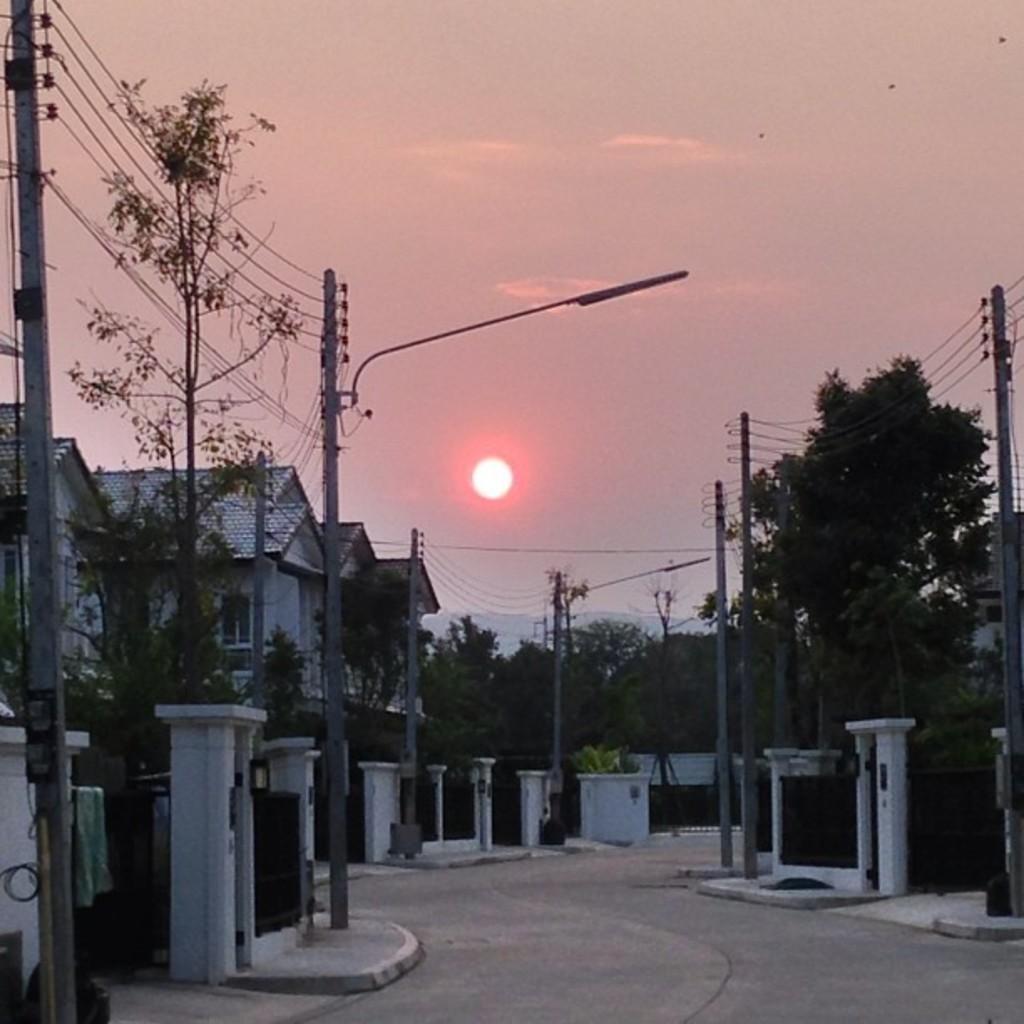In one or two sentences, can you explain what this image depicts? In the image there are many buildings with walls, windows and roofs. In front of the buildings there are pillars, walls and gates. There are electrical poles with wires and street lights. In the background there are many trees. At the top of the image there is sky with sun. 